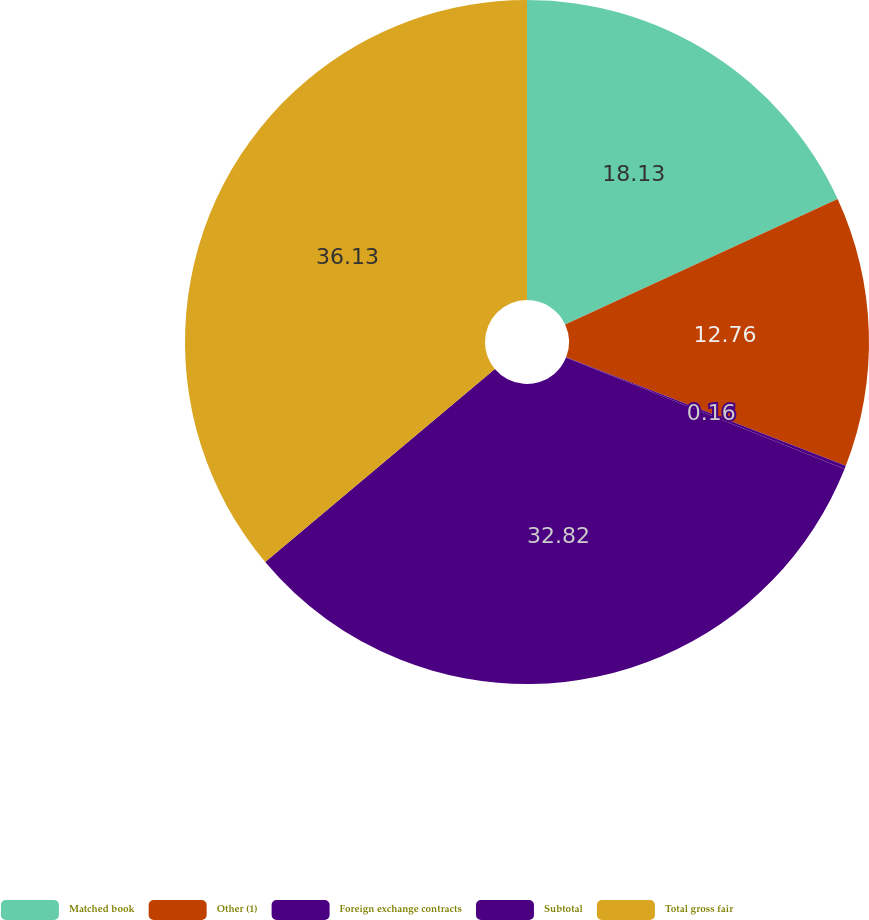Convert chart. <chart><loc_0><loc_0><loc_500><loc_500><pie_chart><fcel>Matched book<fcel>Other (1)<fcel>Foreign exchange contracts<fcel>Subtotal<fcel>Total gross fair<nl><fcel>18.13%<fcel>12.76%<fcel>0.16%<fcel>32.82%<fcel>36.12%<nl></chart> 